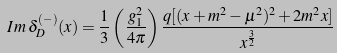<formula> <loc_0><loc_0><loc_500><loc_500>I m \, \delta _ { D } ^ { ( - ) } ( x ) = \frac { 1 } { 3 } \left ( \frac { g ^ { 2 } _ { 1 } } { 4 \pi } \right ) \frac { q [ ( x + m ^ { 2 } - \mu ^ { 2 } ) ^ { 2 } + 2 m ^ { 2 } x ] } { x ^ { \frac { 3 } { 2 } } }</formula> 